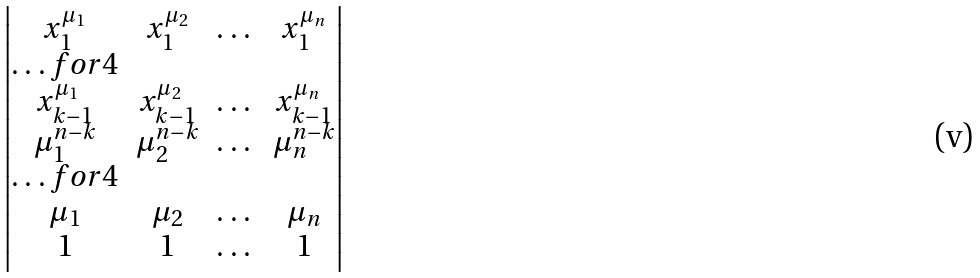Convert formula to latex. <formula><loc_0><loc_0><loc_500><loc_500>\begin{vmatrix} x _ { 1 } ^ { \mu _ { 1 } } & x _ { 1 } ^ { \mu _ { 2 } } & \dots & x _ { 1 } ^ { \mu _ { n } } \\ \hdots f o r { 4 } \\ x _ { k - 1 } ^ { \mu _ { 1 } } & x _ { k - 1 } ^ { \mu _ { 2 } } & \dots & x _ { k - 1 } ^ { \mu _ { n } } \\ \mu _ { 1 } ^ { n - k } & \mu _ { 2 } ^ { n - k } & \dots & \mu _ { n } ^ { n - k } \\ \hdots f o r { 4 } \\ \mu _ { 1 } & \mu _ { 2 } & \dots & \mu _ { n } \\ 1 & 1 & \dots & 1 \end{vmatrix}</formula> 